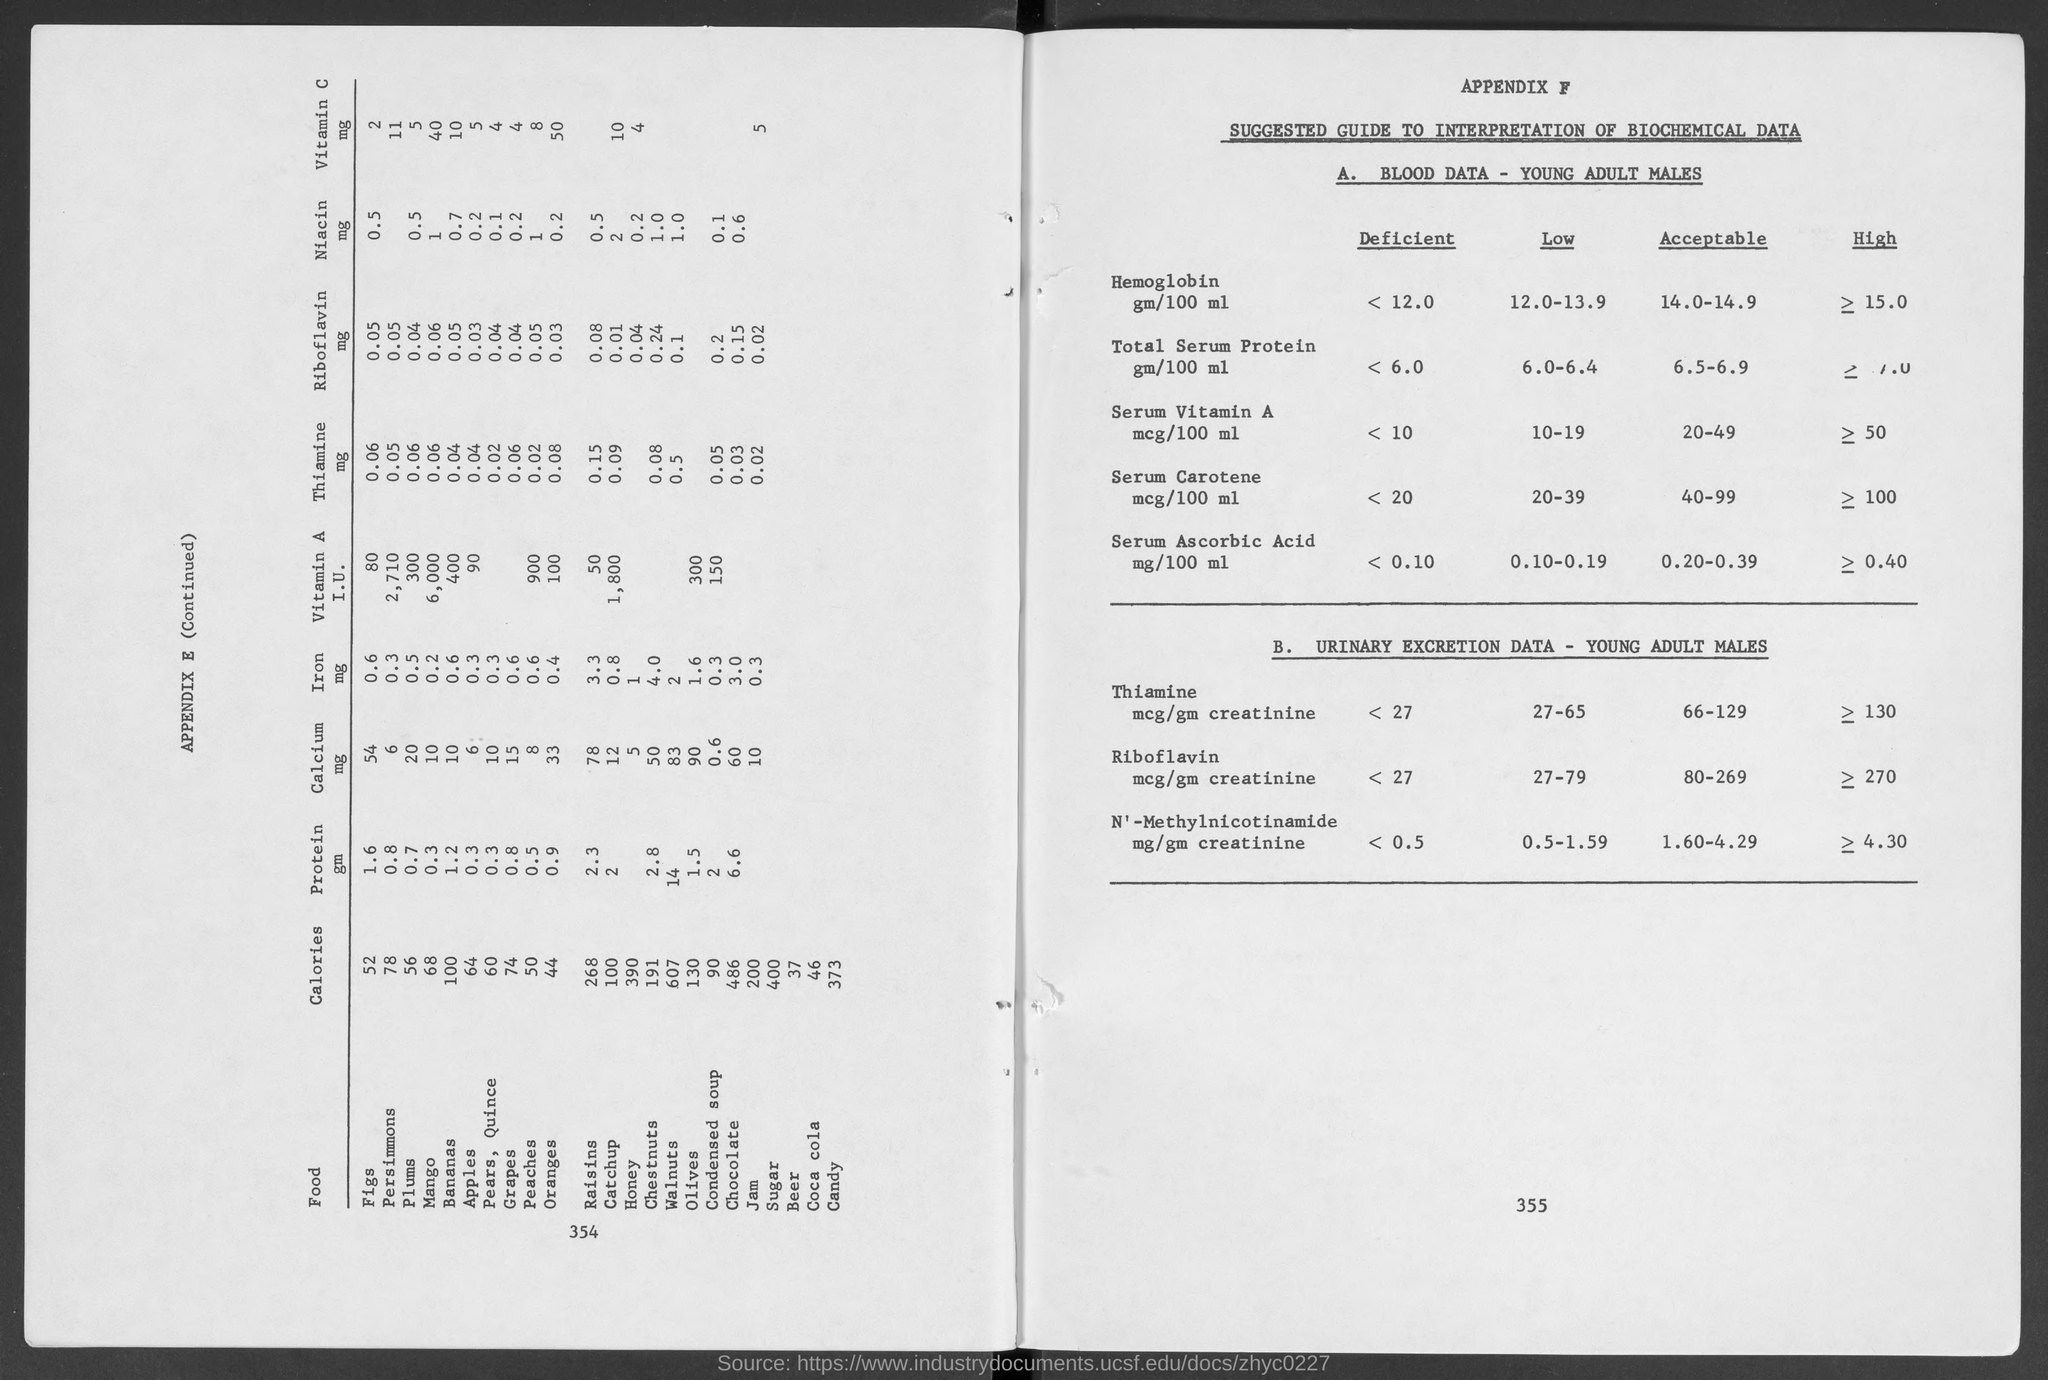Highlight a few significant elements in this photo. The document titled "APPENDIX F" is a guide that provides information on how to interpret biochemical data. The acceptable range for serum ascorbic acid is 0.20-0.39 mg/100 ml. The amount of Niacin in 0.5 plums is 0.5 milligrams. Appendix E lists a variety of foods, and among them, the food with the lowest number of calories is beer. The acceptable level of serum carotene in young adult males is between 40 and 99 micrograms per 100 milliliters. 